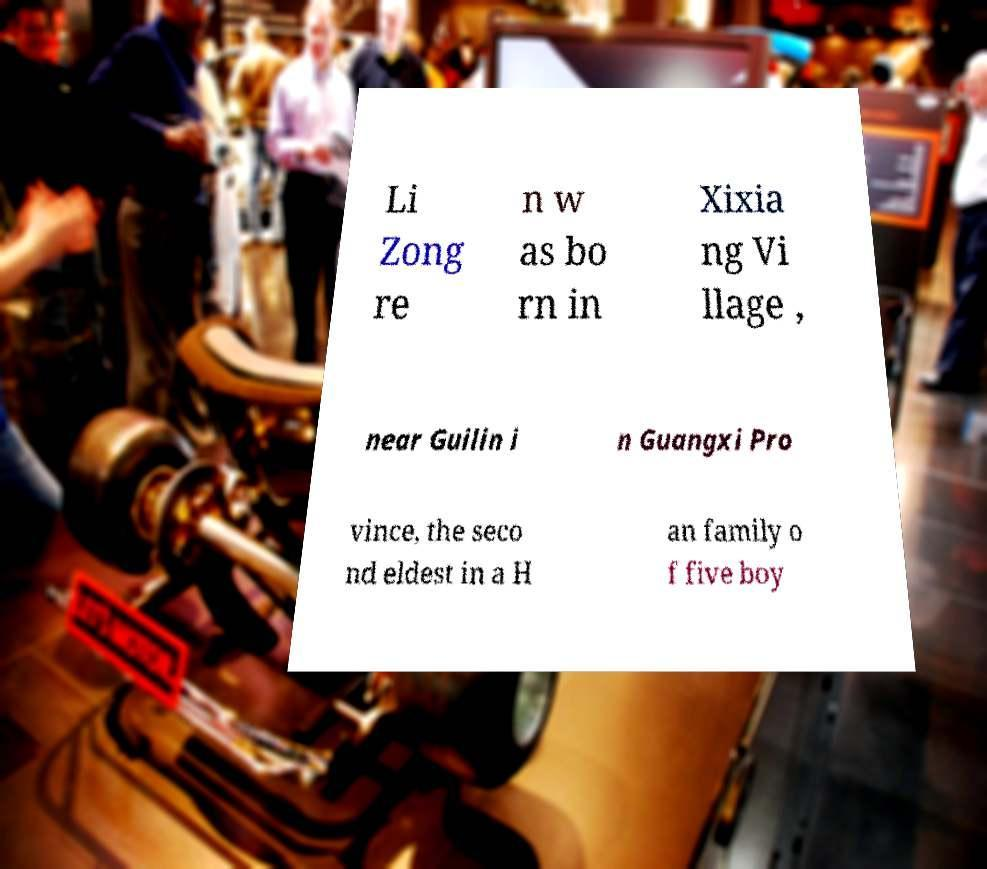Can you read and provide the text displayed in the image?This photo seems to have some interesting text. Can you extract and type it out for me? Li Zong re n w as bo rn in Xixia ng Vi llage , near Guilin i n Guangxi Pro vince, the seco nd eldest in a H an family o f five boy 